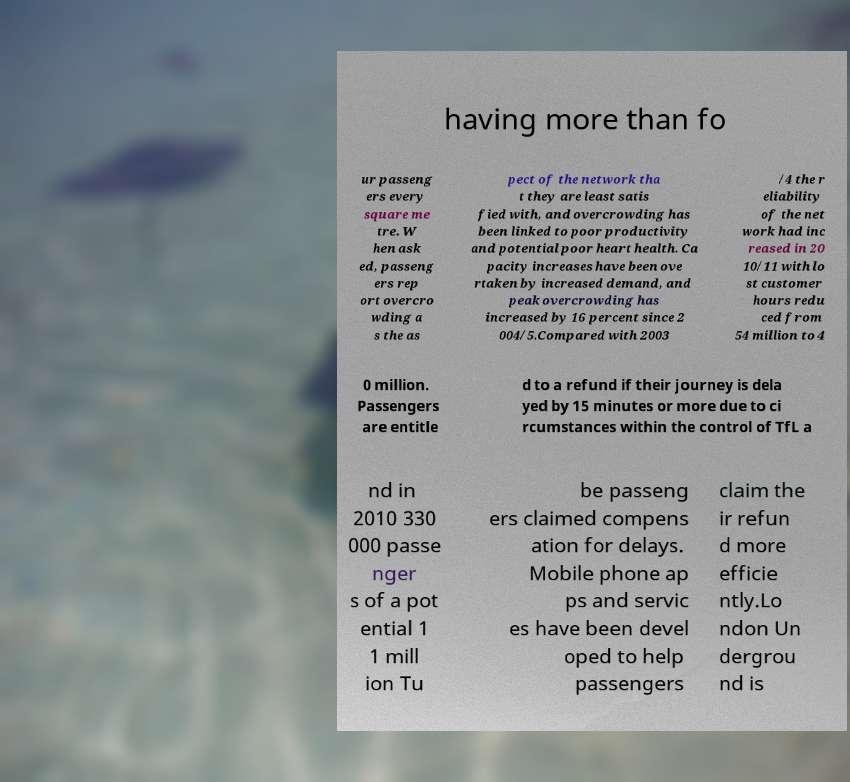Could you assist in decoding the text presented in this image and type it out clearly? having more than fo ur passeng ers every square me tre. W hen ask ed, passeng ers rep ort overcro wding a s the as pect of the network tha t they are least satis fied with, and overcrowding has been linked to poor productivity and potential poor heart health. Ca pacity increases have been ove rtaken by increased demand, and peak overcrowding has increased by 16 percent since 2 004/5.Compared with 2003 /4 the r eliability of the net work had inc reased in 20 10/11 with lo st customer hours redu ced from 54 million to 4 0 million. Passengers are entitle d to a refund if their journey is dela yed by 15 minutes or more due to ci rcumstances within the control of TfL a nd in 2010 330 000 passe nger s of a pot ential 1 1 mill ion Tu be passeng ers claimed compens ation for delays. Mobile phone ap ps and servic es have been devel oped to help passengers claim the ir refun d more efficie ntly.Lo ndon Un dergrou nd is 